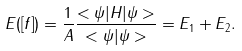Convert formula to latex. <formula><loc_0><loc_0><loc_500><loc_500>E ( [ f ] ) = \frac { 1 } { A } \frac { < \psi | H | \psi > } { < \psi | \psi > } = E _ { 1 } + E _ { 2 } .</formula> 